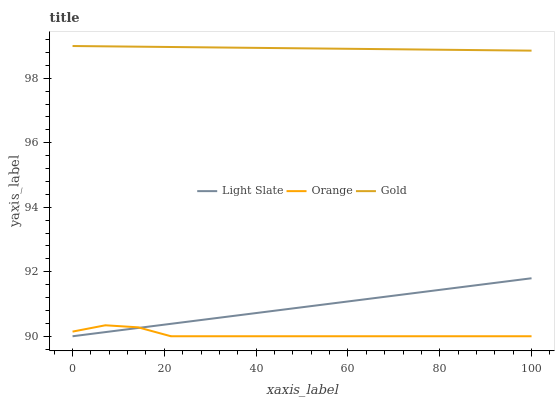Does Orange have the minimum area under the curve?
Answer yes or no. Yes. Does Gold have the maximum area under the curve?
Answer yes or no. Yes. Does Gold have the minimum area under the curve?
Answer yes or no. No. Does Orange have the maximum area under the curve?
Answer yes or no. No. Is Light Slate the smoothest?
Answer yes or no. Yes. Is Orange the roughest?
Answer yes or no. Yes. Is Gold the smoothest?
Answer yes or no. No. Is Gold the roughest?
Answer yes or no. No. Does Light Slate have the lowest value?
Answer yes or no. Yes. Does Gold have the lowest value?
Answer yes or no. No. Does Gold have the highest value?
Answer yes or no. Yes. Does Orange have the highest value?
Answer yes or no. No. Is Light Slate less than Gold?
Answer yes or no. Yes. Is Gold greater than Orange?
Answer yes or no. Yes. Does Light Slate intersect Orange?
Answer yes or no. Yes. Is Light Slate less than Orange?
Answer yes or no. No. Is Light Slate greater than Orange?
Answer yes or no. No. Does Light Slate intersect Gold?
Answer yes or no. No. 